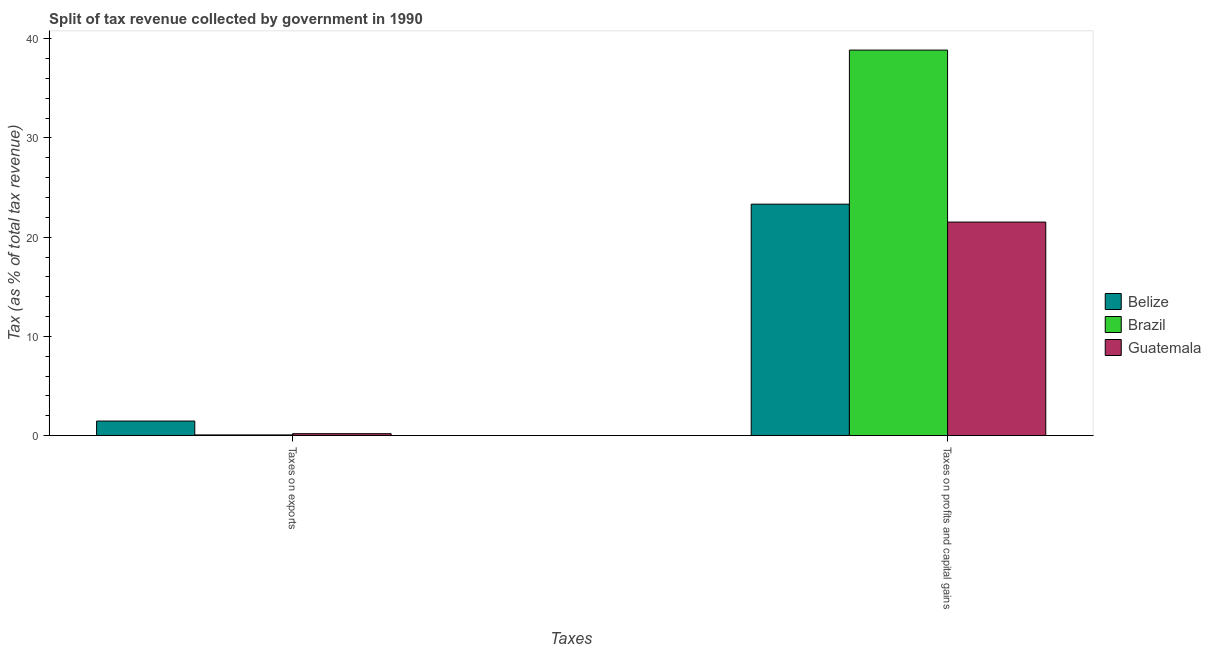How many different coloured bars are there?
Offer a terse response. 3. Are the number of bars on each tick of the X-axis equal?
Offer a very short reply. Yes. How many bars are there on the 2nd tick from the right?
Make the answer very short. 3. What is the label of the 2nd group of bars from the left?
Offer a terse response. Taxes on profits and capital gains. What is the percentage of revenue obtained from taxes on exports in Guatemala?
Your answer should be very brief. 0.2. Across all countries, what is the maximum percentage of revenue obtained from taxes on profits and capital gains?
Offer a very short reply. 38.85. Across all countries, what is the minimum percentage of revenue obtained from taxes on profits and capital gains?
Provide a short and direct response. 21.52. In which country was the percentage of revenue obtained from taxes on exports minimum?
Provide a succinct answer. Brazil. What is the total percentage of revenue obtained from taxes on profits and capital gains in the graph?
Your answer should be compact. 83.69. What is the difference between the percentage of revenue obtained from taxes on exports in Guatemala and that in Brazil?
Provide a short and direct response. 0.12. What is the difference between the percentage of revenue obtained from taxes on profits and capital gains in Brazil and the percentage of revenue obtained from taxes on exports in Belize?
Provide a short and direct response. 37.38. What is the average percentage of revenue obtained from taxes on exports per country?
Make the answer very short. 0.58. What is the difference between the percentage of revenue obtained from taxes on profits and capital gains and percentage of revenue obtained from taxes on exports in Brazil?
Give a very brief answer. 38.78. What is the ratio of the percentage of revenue obtained from taxes on profits and capital gains in Belize to that in Brazil?
Keep it short and to the point. 0.6. Is the percentage of revenue obtained from taxes on exports in Brazil less than that in Guatemala?
Make the answer very short. Yes. What does the 3rd bar from the left in Taxes on exports represents?
Offer a very short reply. Guatemala. What does the 2nd bar from the right in Taxes on exports represents?
Give a very brief answer. Brazil. How many bars are there?
Your answer should be very brief. 6. Where does the legend appear in the graph?
Provide a succinct answer. Center right. How many legend labels are there?
Provide a short and direct response. 3. How are the legend labels stacked?
Your answer should be compact. Vertical. What is the title of the graph?
Ensure brevity in your answer.  Split of tax revenue collected by government in 1990. Does "Moldova" appear as one of the legend labels in the graph?
Offer a terse response. No. What is the label or title of the X-axis?
Make the answer very short. Taxes. What is the label or title of the Y-axis?
Your answer should be very brief. Tax (as % of total tax revenue). What is the Tax (as % of total tax revenue) in Belize in Taxes on exports?
Your answer should be very brief. 1.47. What is the Tax (as % of total tax revenue) in Brazil in Taxes on exports?
Give a very brief answer. 0.07. What is the Tax (as % of total tax revenue) of Guatemala in Taxes on exports?
Your answer should be very brief. 0.2. What is the Tax (as % of total tax revenue) of Belize in Taxes on profits and capital gains?
Make the answer very short. 23.33. What is the Tax (as % of total tax revenue) in Brazil in Taxes on profits and capital gains?
Provide a short and direct response. 38.85. What is the Tax (as % of total tax revenue) in Guatemala in Taxes on profits and capital gains?
Make the answer very short. 21.52. Across all Taxes, what is the maximum Tax (as % of total tax revenue) of Belize?
Make the answer very short. 23.33. Across all Taxes, what is the maximum Tax (as % of total tax revenue) of Brazil?
Give a very brief answer. 38.85. Across all Taxes, what is the maximum Tax (as % of total tax revenue) of Guatemala?
Make the answer very short. 21.52. Across all Taxes, what is the minimum Tax (as % of total tax revenue) in Belize?
Your answer should be compact. 1.47. Across all Taxes, what is the minimum Tax (as % of total tax revenue) in Brazil?
Provide a short and direct response. 0.07. Across all Taxes, what is the minimum Tax (as % of total tax revenue) in Guatemala?
Ensure brevity in your answer.  0.2. What is the total Tax (as % of total tax revenue) of Belize in the graph?
Ensure brevity in your answer.  24.8. What is the total Tax (as % of total tax revenue) in Brazil in the graph?
Provide a succinct answer. 38.92. What is the total Tax (as % of total tax revenue) of Guatemala in the graph?
Give a very brief answer. 21.72. What is the difference between the Tax (as % of total tax revenue) of Belize in Taxes on exports and that in Taxes on profits and capital gains?
Keep it short and to the point. -21.85. What is the difference between the Tax (as % of total tax revenue) of Brazil in Taxes on exports and that in Taxes on profits and capital gains?
Ensure brevity in your answer.  -38.78. What is the difference between the Tax (as % of total tax revenue) of Guatemala in Taxes on exports and that in Taxes on profits and capital gains?
Offer a very short reply. -21.32. What is the difference between the Tax (as % of total tax revenue) in Belize in Taxes on exports and the Tax (as % of total tax revenue) in Brazil in Taxes on profits and capital gains?
Give a very brief answer. -37.38. What is the difference between the Tax (as % of total tax revenue) in Belize in Taxes on exports and the Tax (as % of total tax revenue) in Guatemala in Taxes on profits and capital gains?
Your response must be concise. -20.05. What is the difference between the Tax (as % of total tax revenue) of Brazil in Taxes on exports and the Tax (as % of total tax revenue) of Guatemala in Taxes on profits and capital gains?
Keep it short and to the point. -21.45. What is the average Tax (as % of total tax revenue) of Belize per Taxes?
Make the answer very short. 12.4. What is the average Tax (as % of total tax revenue) in Brazil per Taxes?
Offer a very short reply. 19.46. What is the average Tax (as % of total tax revenue) in Guatemala per Taxes?
Keep it short and to the point. 10.86. What is the difference between the Tax (as % of total tax revenue) in Belize and Tax (as % of total tax revenue) in Brazil in Taxes on exports?
Your answer should be very brief. 1.4. What is the difference between the Tax (as % of total tax revenue) of Belize and Tax (as % of total tax revenue) of Guatemala in Taxes on exports?
Provide a succinct answer. 1.27. What is the difference between the Tax (as % of total tax revenue) of Brazil and Tax (as % of total tax revenue) of Guatemala in Taxes on exports?
Your answer should be compact. -0.12. What is the difference between the Tax (as % of total tax revenue) in Belize and Tax (as % of total tax revenue) in Brazil in Taxes on profits and capital gains?
Offer a very short reply. -15.52. What is the difference between the Tax (as % of total tax revenue) in Belize and Tax (as % of total tax revenue) in Guatemala in Taxes on profits and capital gains?
Offer a very short reply. 1.81. What is the difference between the Tax (as % of total tax revenue) of Brazil and Tax (as % of total tax revenue) of Guatemala in Taxes on profits and capital gains?
Provide a short and direct response. 17.33. What is the ratio of the Tax (as % of total tax revenue) in Belize in Taxes on exports to that in Taxes on profits and capital gains?
Your answer should be compact. 0.06. What is the ratio of the Tax (as % of total tax revenue) of Brazil in Taxes on exports to that in Taxes on profits and capital gains?
Make the answer very short. 0. What is the ratio of the Tax (as % of total tax revenue) in Guatemala in Taxes on exports to that in Taxes on profits and capital gains?
Give a very brief answer. 0.01. What is the difference between the highest and the second highest Tax (as % of total tax revenue) in Belize?
Provide a short and direct response. 21.85. What is the difference between the highest and the second highest Tax (as % of total tax revenue) in Brazil?
Provide a succinct answer. 38.78. What is the difference between the highest and the second highest Tax (as % of total tax revenue) of Guatemala?
Provide a succinct answer. 21.32. What is the difference between the highest and the lowest Tax (as % of total tax revenue) of Belize?
Provide a succinct answer. 21.85. What is the difference between the highest and the lowest Tax (as % of total tax revenue) in Brazil?
Your answer should be compact. 38.78. What is the difference between the highest and the lowest Tax (as % of total tax revenue) in Guatemala?
Your response must be concise. 21.32. 